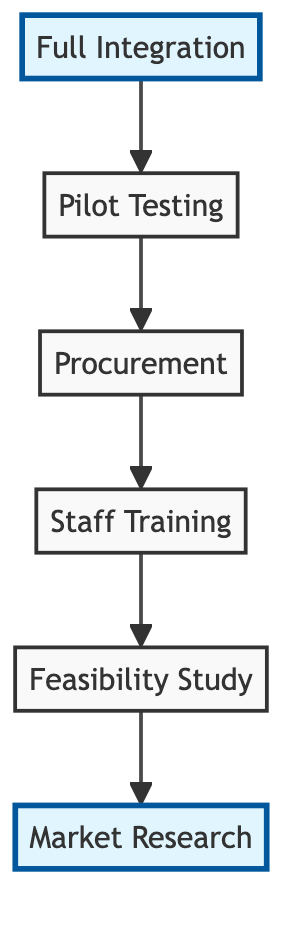What is the first step in the adoption process? The first step in the adoption process, as indicated at the bottom of the diagram, is "Market Research."
Answer: Market Research How many steps are involved in the adoption process? There are six steps involved in the adoption process, as represented by the six distinct nodes in the diagram: Market Research, Feasibility Study, Staff Training, Procurement, Pilot Testing, and Full Integration.
Answer: Six Which step comes before "Staff Training"? "Procurement" is the step that comes directly before "Staff Training" in the upward flow of the diagram.
Answer: Procurement What is highlighted in the diagram? Both "Market Research" and "Full Integration" nodes are highlighted in the diagram.
Answer: Market Research and Full Integration What step follows "Pilot Testing"? The step that follows "Pilot Testing" in the upward flow is "Procurement."
Answer: Procurement What are the two terminal nodes in the adoption process? The two terminal nodes in the adoption process flow are "Market Research" at the bottom and "Full Integration" at the top.
Answer: Market Research and Full Integration Which step evaluates clinical studies and success rates? "Feasibility Study" is the step that evaluates clinical studies and success rates.
Answer: Feasibility Study Which step involves negotiations with suppliers? "Procurement" is the step that involves negotiations with suppliers for the best terms and warranties.
Answer: Procurement What is the last step in the flow chart? The last step in the flow chart, at the top, is "Full Integration."
Answer: Full Integration 